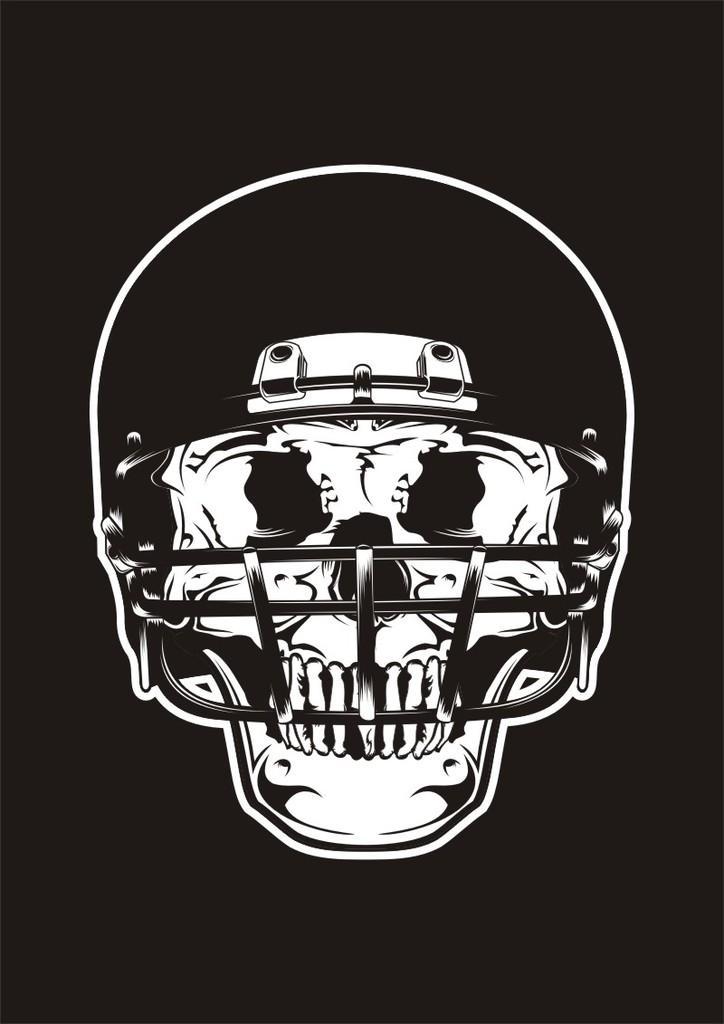Can you describe this image briefly? In the image we can see there is a skull wearing helmet and the image is in black and white colour. 